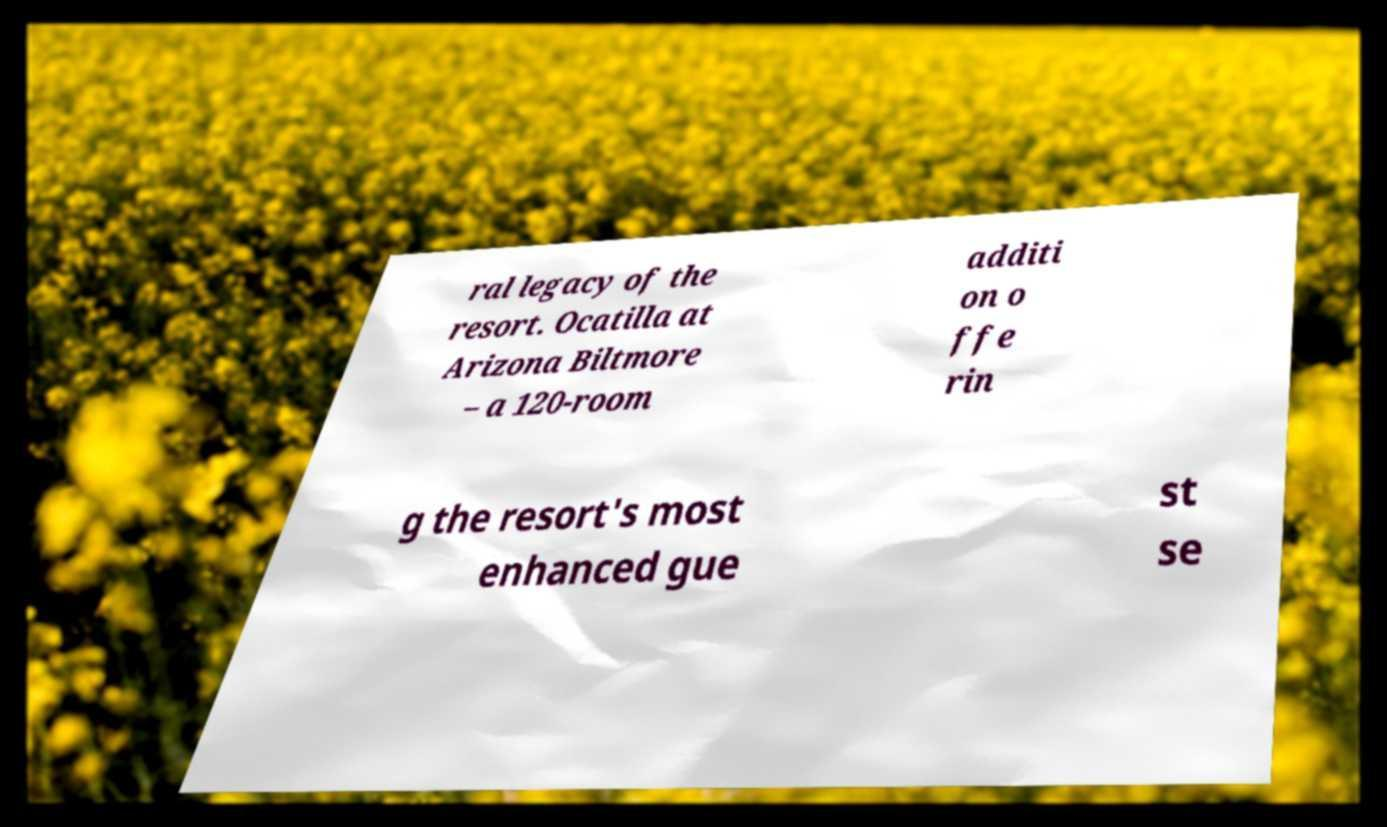I need the written content from this picture converted into text. Can you do that? ral legacy of the resort. Ocatilla at Arizona Biltmore – a 120-room additi on o ffe rin g the resort's most enhanced gue st se 